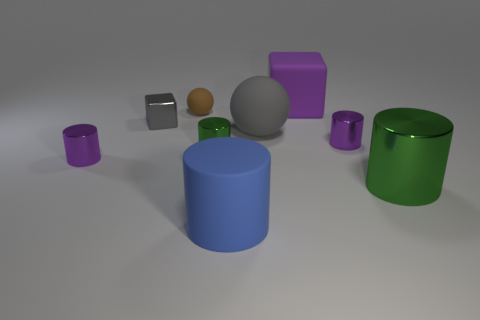Subtract all large green shiny cylinders. How many cylinders are left? 4 Subtract all purple cubes. How many cubes are left? 1 Subtract all cylinders. How many objects are left? 4 Subtract 2 blocks. How many blocks are left? 0 Subtract all purple blocks. Subtract all cyan cylinders. How many blocks are left? 1 Subtract all cyan cylinders. How many gray cubes are left? 1 Subtract all small brown rubber cylinders. Subtract all small blocks. How many objects are left? 8 Add 1 gray metallic blocks. How many gray metallic blocks are left? 2 Add 6 small green matte blocks. How many small green matte blocks exist? 6 Subtract 1 purple blocks. How many objects are left? 8 